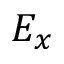<formula> <loc_0><loc_0><loc_500><loc_500>E _ { x }</formula> 